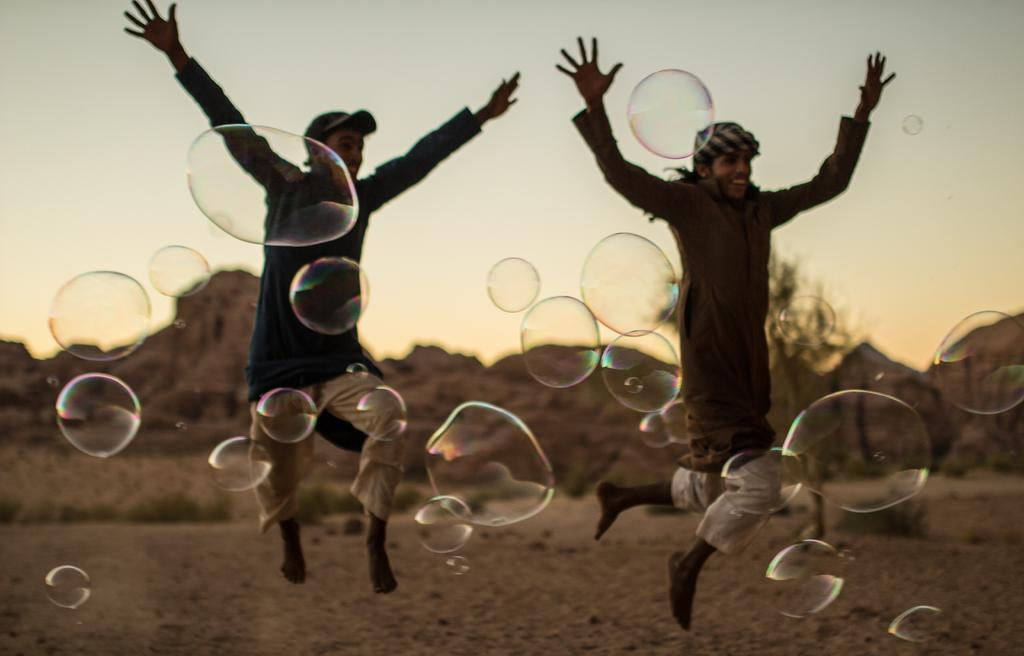What are the men in the image doing? The men in the image are flying in the air. What can be seen in the background of the image? Hills, the sky, trees, and the ground are visible in the background of the image. What is present in the foreground of the image? Water bubbles are present in the foreground of the image. What type of point is the ladybug making in the image? There is no ladybug present in the image, so it cannot be making any points. 